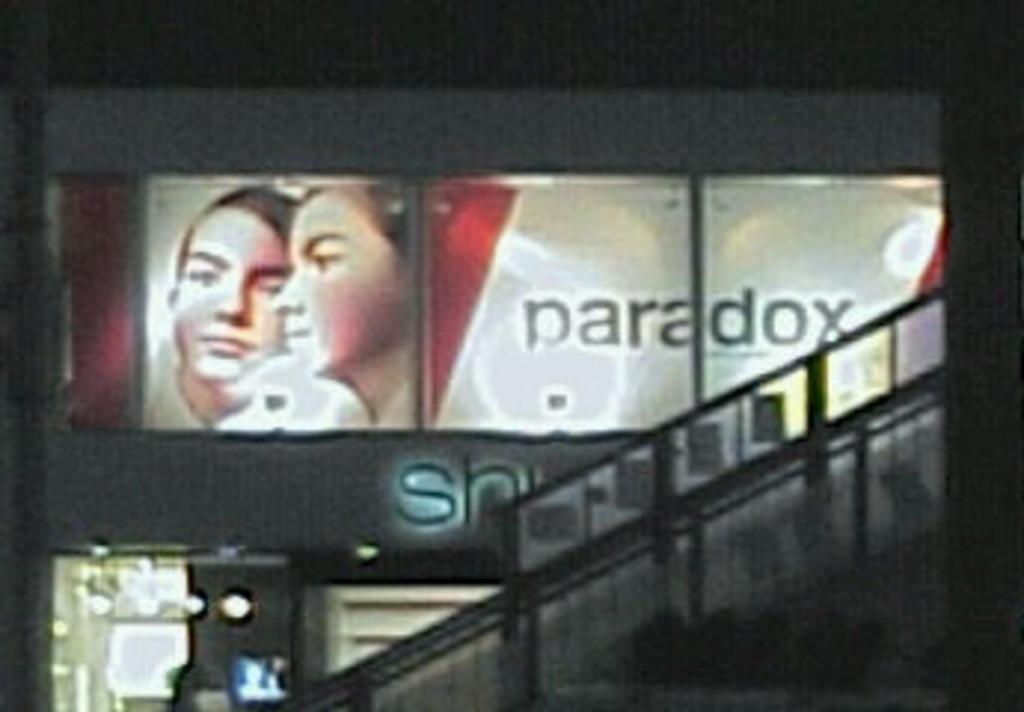Please provide a concise description of this image. In the picture I can see an LED hoarding board in the middle of the image. In the hoarding I can see the faces of two persons and a text. These are looking like lamps on the bottom left side of the picture. It is looking like a glass fencing on the right side. 